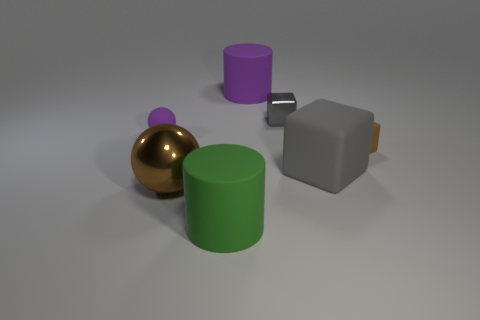Add 2 tiny purple matte cubes. How many objects exist? 9 Subtract all balls. How many objects are left? 5 Subtract all rubber cubes. Subtract all green things. How many objects are left? 4 Add 7 spheres. How many spheres are left? 9 Add 4 big green rubber cylinders. How many big green rubber cylinders exist? 5 Subtract 0 gray spheres. How many objects are left? 7 